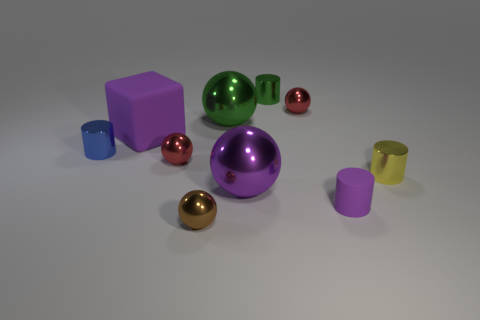There is a small cylinder in front of the purple ball; is it the same color as the big shiny sphere that is in front of the blue shiny cylinder?
Your answer should be compact. Yes. There is a small red ball that is in front of the block; what material is it?
Keep it short and to the point. Metal. The object that is made of the same material as the purple cylinder is what color?
Offer a very short reply. Purple. What number of brown balls have the same size as the brown shiny object?
Provide a short and direct response. 0. Does the cylinder that is in front of the yellow metal thing have the same size as the tiny green metallic cylinder?
Your answer should be compact. Yes. There is a tiny shiny object that is in front of the blue shiny cylinder and left of the brown ball; what is its shape?
Your answer should be very brief. Sphere. There is a yellow cylinder; are there any tiny yellow things left of it?
Ensure brevity in your answer.  No. Is there anything else that has the same shape as the big purple matte thing?
Your answer should be compact. No. Does the tiny purple object have the same shape as the large purple rubber thing?
Your response must be concise. No. Is the number of purple cylinders that are behind the block the same as the number of brown metallic balls that are in front of the small brown ball?
Ensure brevity in your answer.  Yes. 